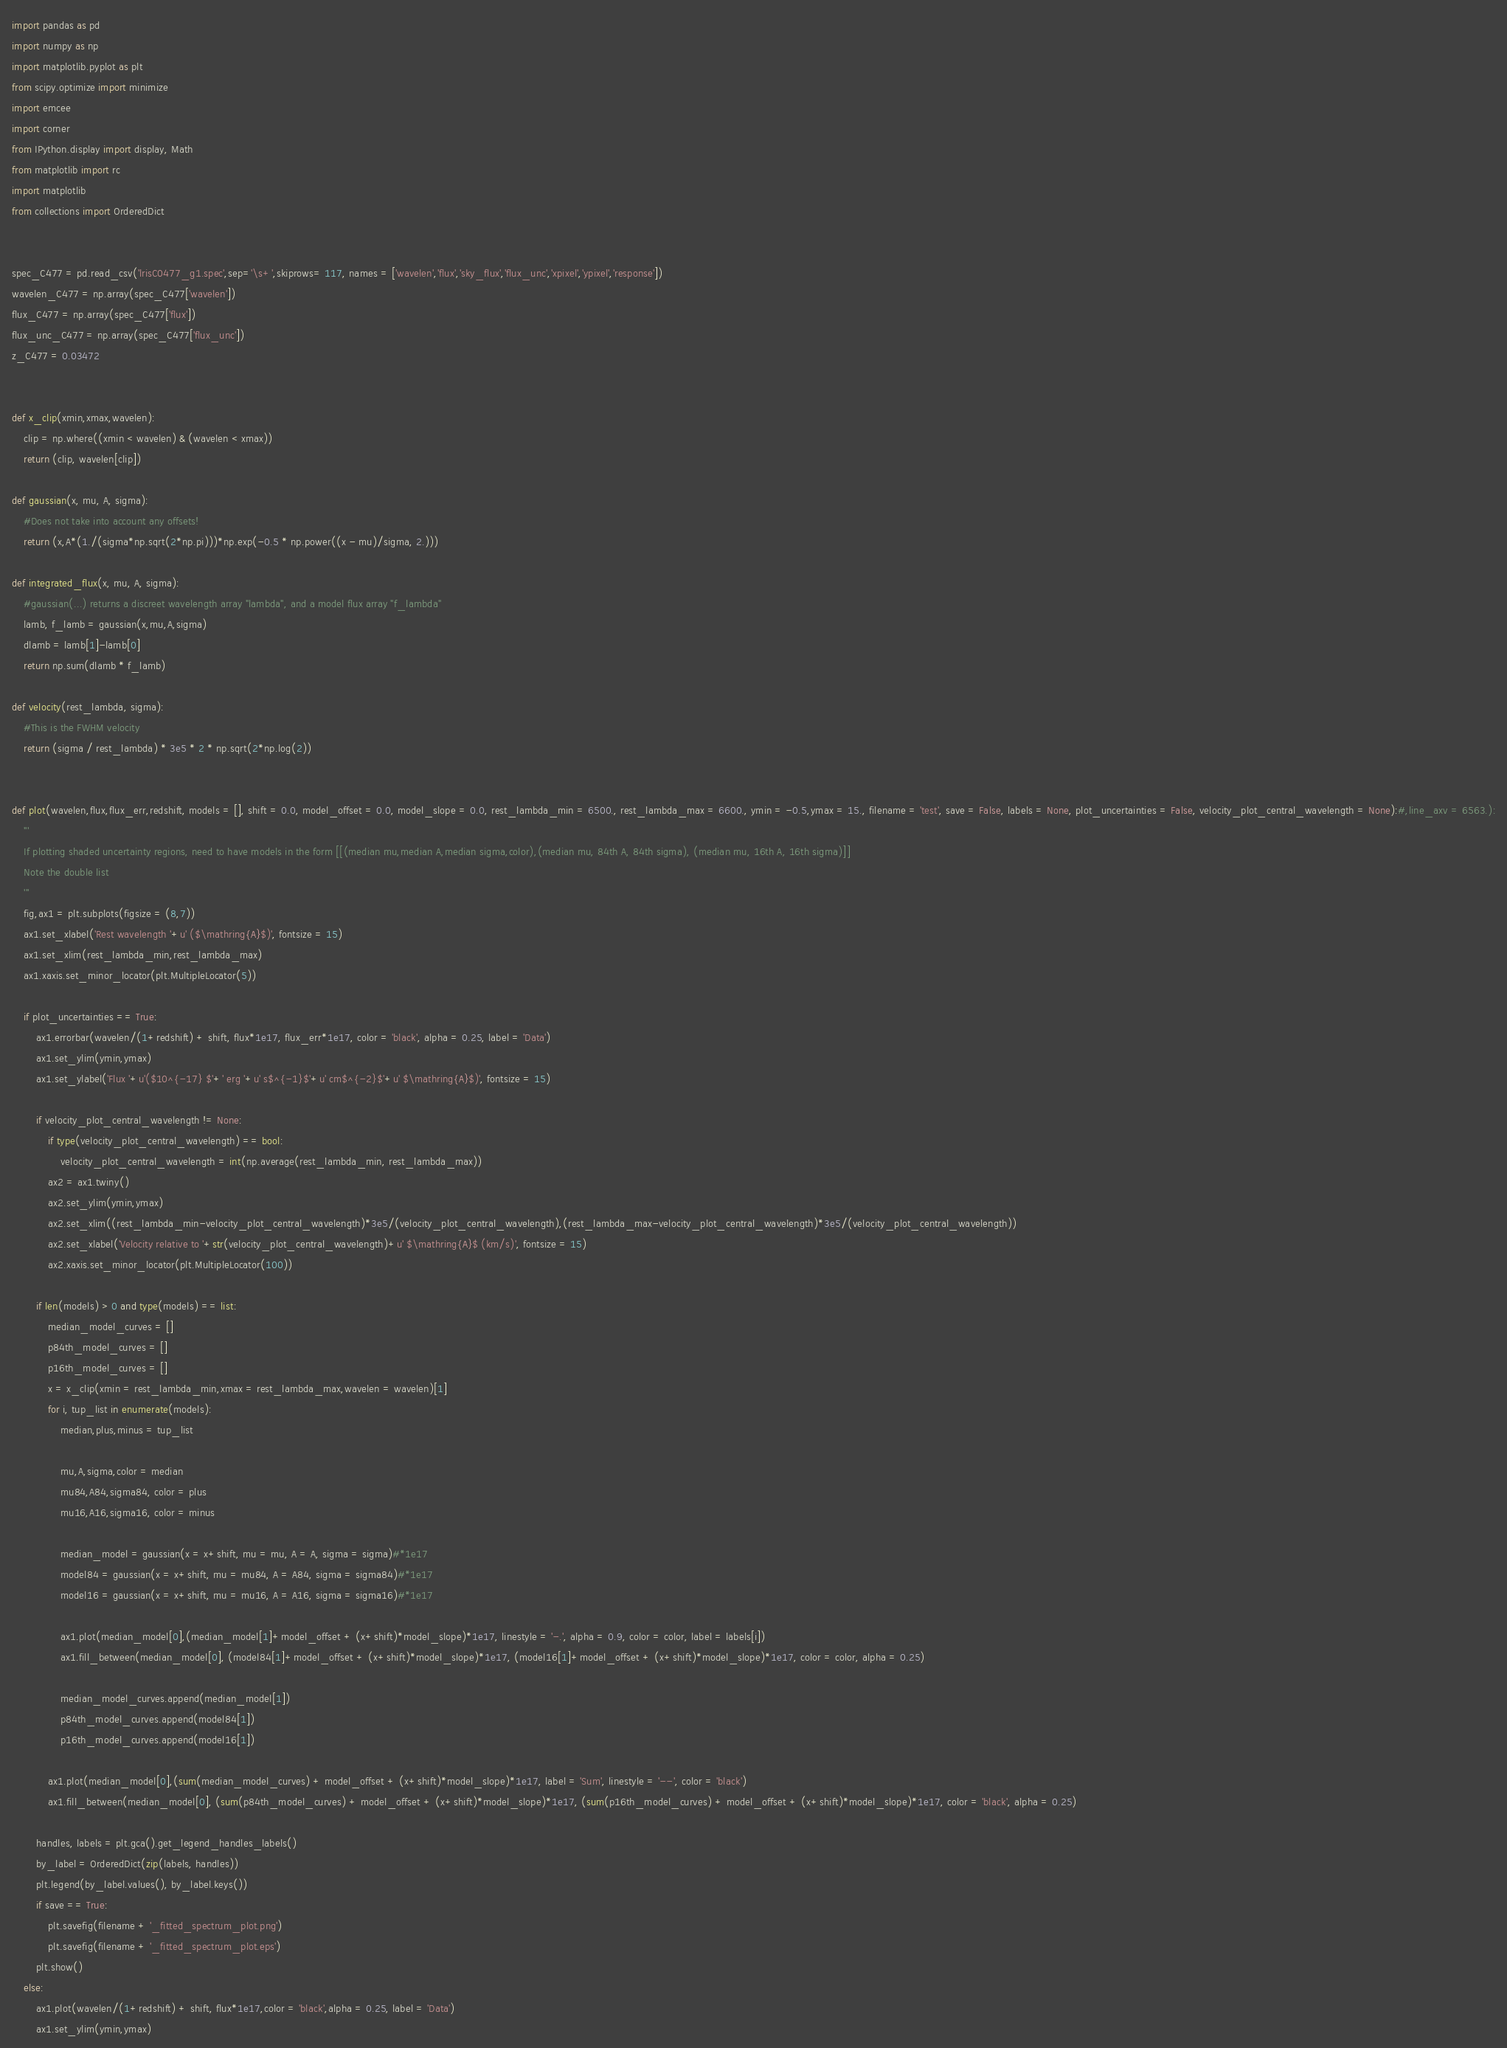<code> <loc_0><loc_0><loc_500><loc_500><_Python_>import pandas as pd 
import numpy as np 
import matplotlib.pyplot as plt 
from scipy.optimize import minimize
import emcee
import corner
from IPython.display import display, Math
from matplotlib import rc
import matplotlib
from collections import OrderedDict


spec_C477 = pd.read_csv('lrisC0477_g1.spec',sep='\s+',skiprows= 117, names = ['wavelen','flux','sky_flux','flux_unc','xpixel','ypixel','response'])
wavelen_C477 = np.array(spec_C477['wavelen'])
flux_C477 = np.array(spec_C477['flux'])
flux_unc_C477 = np.array(spec_C477['flux_unc'])
z_C477 = 0.03472


def x_clip(xmin,xmax,wavelen):
    clip = np.where((xmin < wavelen) & (wavelen < xmax))
    return (clip, wavelen[clip])

def gaussian(x, mu, A, sigma):
    #Does not take into account any offsets!
    return (x,A*(1./(sigma*np.sqrt(2*np.pi)))*np.exp(-0.5 * np.power((x - mu)/sigma, 2.)))

def integrated_flux(x, mu, A, sigma):
    #gaussian(...) returns a discreet wavelength array "lambda", and a model flux array "f_lambda"
    lamb, f_lamb = gaussian(x,mu,A,sigma)
    dlamb = lamb[1]-lamb[0]
    return np.sum(dlamb * f_lamb)

def velocity(rest_lambda, sigma):
    #This is the FWHM velocity
    return (sigma / rest_lambda) * 3e5 * 2 * np.sqrt(2*np.log(2))


def plot(wavelen,flux,flux_err,redshift, models = [], shift = 0.0, model_offset = 0.0, model_slope = 0.0, rest_lambda_min = 6500., rest_lambda_max = 6600., ymin = -0.5,ymax = 15., filename = 'test', save = False, labels = None, plot_uncertainties = False, velocity_plot_central_wavelength = None):#,line_axv = 6563.):
    '''
    If plotting shaded uncertainty regions, need to have models in the form [[(median mu,median A,median sigma,color),(median mu, 84th A, 84th sigma), (median mu, 16th A, 16th sigma)]]
    Note the double list
    '''
    fig,ax1 = plt.subplots(figsize = (8,7))
    ax1.set_xlabel('Rest wavelength '+u' ($\mathring{A}$)', fontsize = 15)
    ax1.set_xlim(rest_lambda_min,rest_lambda_max)
    ax1.xaxis.set_minor_locator(plt.MultipleLocator(5))
    
    if plot_uncertainties == True:
        ax1.errorbar(wavelen/(1+redshift) + shift, flux*1e17, flux_err*1e17, color = 'black', alpha = 0.25, label = 'Data')
        ax1.set_ylim(ymin,ymax)
        ax1.set_ylabel('Flux '+u'($10^{-17} $'+' erg '+u' s$^{-1}$'+u' cm$^{-2}$'+u' $\mathring{A}$)', fontsize = 15)
        
        if velocity_plot_central_wavelength != None:
            if type(velocity_plot_central_wavelength) == bool:
                velocity_plot_central_wavelength = int(np.average(rest_lambda_min, rest_lambda_max))
            ax2 = ax1.twiny()
            ax2.set_ylim(ymin,ymax)
            ax2.set_xlim((rest_lambda_min-velocity_plot_central_wavelength)*3e5/(velocity_plot_central_wavelength),(rest_lambda_max-velocity_plot_central_wavelength)*3e5/(velocity_plot_central_wavelength))
            ax2.set_xlabel('Velocity relative to '+str(velocity_plot_central_wavelength)+u' $\mathring{A}$ (km/s)', fontsize = 15)
            ax2.xaxis.set_minor_locator(plt.MultipleLocator(100))

        if len(models) > 0 and type(models) == list:
            median_model_curves = []
            p84th_model_curves = []
            p16th_model_curves = []
            x = x_clip(xmin = rest_lambda_min,xmax = rest_lambda_max,wavelen = wavelen)[1]
            for i, tup_list in enumerate(models):
                median,plus,minus = tup_list
                
                mu,A,sigma,color = median 
                mu84,A84,sigma84, color = plus
                mu16,A16,sigma16, color = minus
                
                median_model = gaussian(x = x+shift, mu = mu, A = A, sigma = sigma)#*1e17
                model84 = gaussian(x = x+shift, mu = mu84, A = A84, sigma = sigma84)#*1e17
                model16 = gaussian(x = x+shift, mu = mu16, A = A16, sigma = sigma16)#*1e17

                ax1.plot(median_model[0],(median_model[1]+model_offset + (x+shift)*model_slope)*1e17, linestyle = '-.', alpha = 0.9, color = color, label = labels[i])
                ax1.fill_between(median_model[0], (model84[1]+model_offset + (x+shift)*model_slope)*1e17, (model16[1]+model_offset + (x+shift)*model_slope)*1e17, color = color, alpha = 0.25)
                
                median_model_curves.append(median_model[1])
                p84th_model_curves.append(model84[1])
                p16th_model_curves.append(model16[1])
                
            ax1.plot(median_model[0],(sum(median_model_curves) + model_offset + (x+shift)*model_slope)*1e17, label = 'Sum', linestyle = '--', color = 'black')
            ax1.fill_between(median_model[0], (sum(p84th_model_curves) + model_offset + (x+shift)*model_slope)*1e17, (sum(p16th_model_curves) + model_offset + (x+shift)*model_slope)*1e17, color = 'black', alpha = 0.25)
            
        handles, labels = plt.gca().get_legend_handles_labels()
        by_label = OrderedDict(zip(labels, handles))
        plt.legend(by_label.values(), by_label.keys())
        if save == True:
            plt.savefig(filename + '_fitted_spectrum_plot.png')
            plt.savefig(filename + '_fitted_spectrum_plot.eps')
        plt.show()
    else:
        ax1.plot(wavelen/(1+redshift) + shift, flux*1e17,color = 'black',alpha = 0.25, label = 'Data')
        ax1.set_ylim(ymin,ymax) </code> 